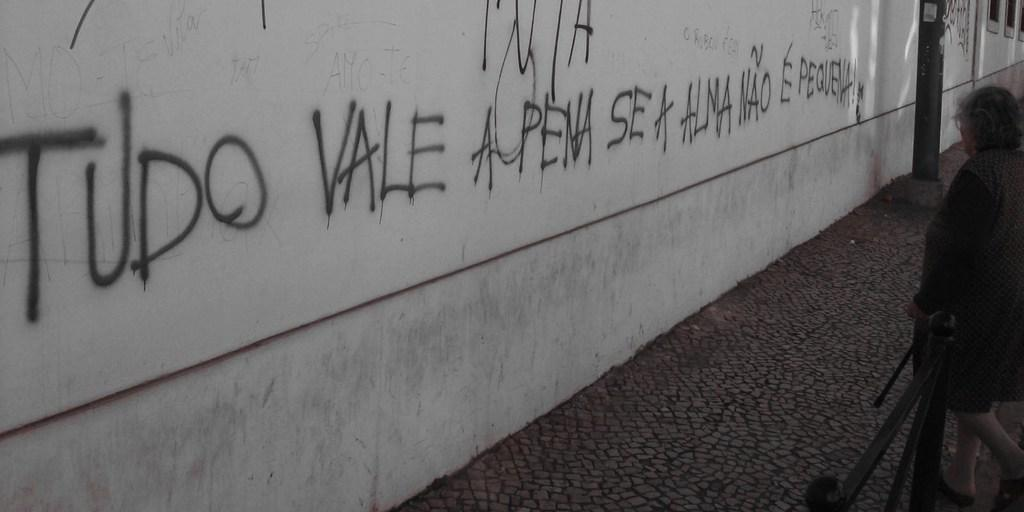What is written on the wall in the image? There is text written on the wall in the image. What is located in front of the wall? There is a metal rod pillar in front of the wall. What is in front of the pillar? There is a metal rod fence in front of the pillar. Who is present in front of the fence? There is a woman standing in front of the fence. What type of stomach pain is the woman experiencing in the image? There is no indication of any stomach pain or discomfort in the image; the woman is simply standing in front of the fence. How many icicles are hanging from the metal rod fence in the image? There are no icicles present in the image; it is a metal rod fence without any ice formations. 